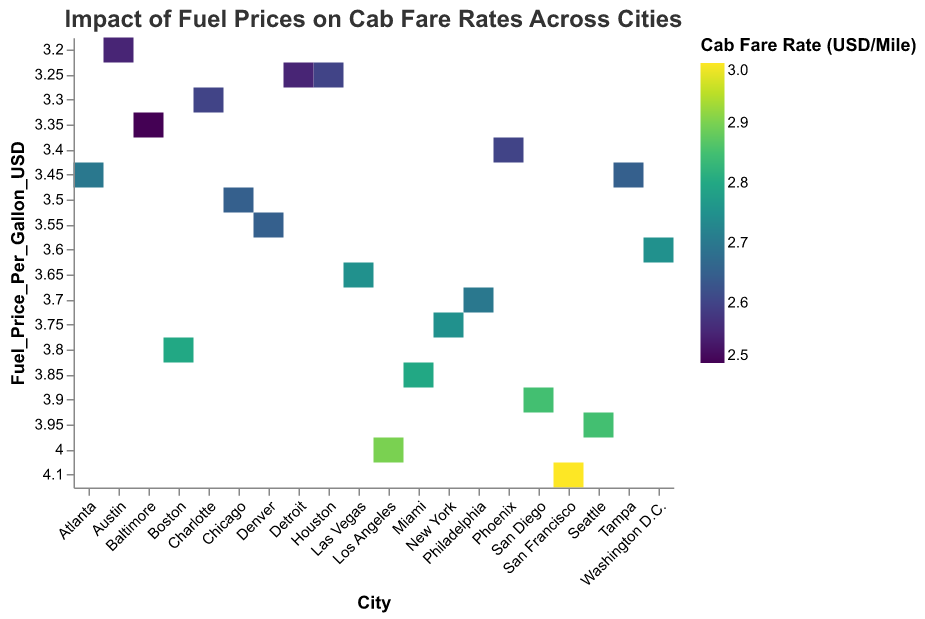What is the title of the heatmap? The title of a figure is usually found at the top and summarizes what the plot represents. In this case, it says "Impact of Fuel Prices on Cab Fare Rates Across Cities."
Answer: Impact of Fuel Prices on Cab Fare Rates Across Cities How many cities are presented in the heatmap? The heatmap has an 'x' axis labeled "City" with each city listed. By counting the entries, we see there are 20 cities displayed.
Answer: 20 Which city has the highest cab fare rate per mile, and what is the rate? By looking at the color intensity corresponding to the legend, darker areas indicate higher cab fare rates. San Francisco shows the darkest color, indicating it has the highest rate. The legend confirms this rate is $3.00 per mile.
Answer: San Francisco, 3.00 Which city has the lowest fuel price per gallon, and what is the price? The 'y' axis represents "Fuel Price Per Gallon (USD)," and by finding the lowest point on this axis, we see Austin has the lowest fuel price at $3.20 per gallon.
Answer: Austin, 3.20 Which cities have a cab fare rate of $2.80 per mile, and what are their fuel prices? Matching the color intensity to the legend value of $2.80, we identify Miami, Boston, and two more cities falling under this rate. Checking ‘y’ axis, their fuel prices are $3.85 (Miami), $3.80 (Boston), and another city with the same rate.
Answer: Miami (3.85), Boston (3.80) On average, what is the fuel price per gallon for New York, Los Angeles, and Chicago? Add the individual fuel prices: $3.75 (New York) + $4.00 (Los Angeles) + $3.50 (Chicago) = $11.25. Then divide by three to find the average: $11.25 / 3 = $3.75.
Answer: 3.75 Is there a correlation between higher fuel prices and higher cab fare rates? Observing the heatmap, areas where fuel prices are high (darker on the y-axis), tend to have higher cab fare rates per mile (darker hues in rectangles). This suggests a correlation.
Answer: Yes How many cities have a fuel price per gallon above $3.90? There’s a fuel price threshold of $3.90 on the 'y' axis. By checking rectangles above this barcode, those cities are Los Angeles, San Francisco, Seattle, and San Diego, totaling four cities.
Answer: 4 Which city has the lowest cab fare rate per mile, and what is the corresponding fuel price? By checking the lightest-colored rectangle, Baltimore shows the lowest fare rate of $2.50 per mile. The fuel price per gallon for Baltimore is $3.35.
Answer: Baltimore, 3.35 Compare the cab fare rates between New York and Philadelphia. Locate both cities in the heatmap and compare the color shades corresponding to their fare rates. Both cities show a similar color shade, indicating a cab fare rate of $2.75, meaning they are equal.
Answer: Equal 